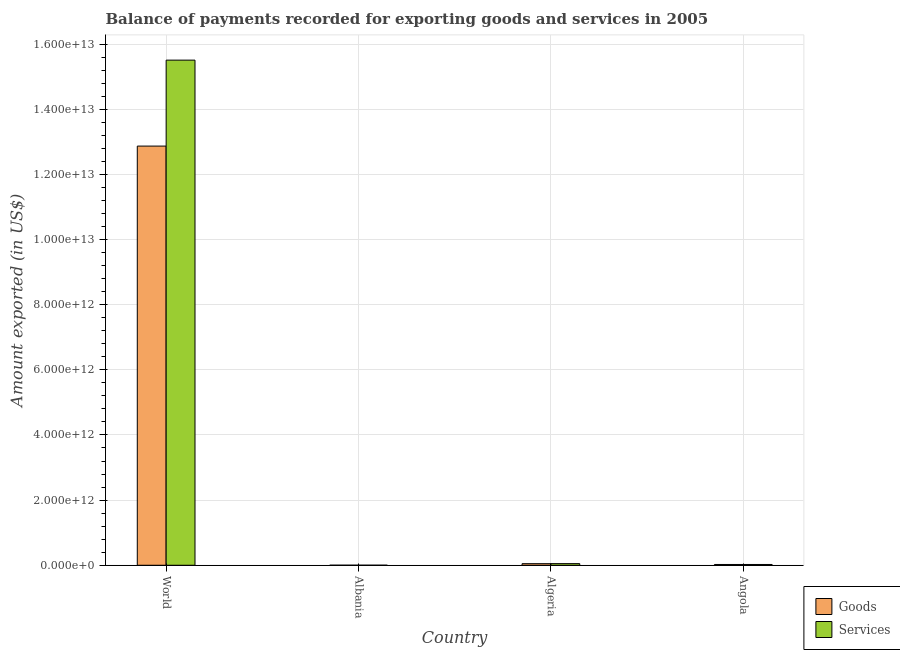How many groups of bars are there?
Ensure brevity in your answer.  4. How many bars are there on the 2nd tick from the left?
Provide a succinct answer. 2. How many bars are there on the 4th tick from the right?
Offer a very short reply. 2. What is the label of the 1st group of bars from the left?
Keep it short and to the point. World. In how many cases, is the number of bars for a given country not equal to the number of legend labels?
Offer a terse response. 0. What is the amount of goods exported in Angola?
Make the answer very short. 2.43e+1. Across all countries, what is the maximum amount of goods exported?
Provide a short and direct response. 1.29e+13. Across all countries, what is the minimum amount of goods exported?
Ensure brevity in your answer.  1.46e+09. In which country was the amount of services exported maximum?
Ensure brevity in your answer.  World. In which country was the amount of goods exported minimum?
Provide a succinct answer. Albania. What is the total amount of goods exported in the graph?
Your answer should be compact. 1.29e+13. What is the difference between the amount of goods exported in Albania and that in World?
Offer a very short reply. -1.29e+13. What is the difference between the amount of goods exported in Algeria and the amount of services exported in Albania?
Your response must be concise. 4.72e+1. What is the average amount of services exported per country?
Your response must be concise. 3.90e+12. What is the difference between the amount of services exported and amount of goods exported in Albania?
Your answer should be very brief. 2.27e+08. In how many countries, is the amount of services exported greater than 2000000000000 US$?
Your response must be concise. 1. What is the ratio of the amount of goods exported in Albania to that in World?
Provide a succinct answer. 0. Is the difference between the amount of services exported in Albania and World greater than the difference between the amount of goods exported in Albania and World?
Give a very brief answer. No. What is the difference between the highest and the second highest amount of services exported?
Offer a terse response. 1.55e+13. What is the difference between the highest and the lowest amount of services exported?
Ensure brevity in your answer.  1.55e+13. What does the 1st bar from the left in Albania represents?
Make the answer very short. Goods. What does the 1st bar from the right in Algeria represents?
Your answer should be very brief. Services. How many bars are there?
Your answer should be compact. 8. What is the difference between two consecutive major ticks on the Y-axis?
Make the answer very short. 2.00e+12. Does the graph contain any zero values?
Offer a terse response. No. Does the graph contain grids?
Ensure brevity in your answer.  Yes. Where does the legend appear in the graph?
Offer a terse response. Bottom right. How are the legend labels stacked?
Offer a very short reply. Vertical. What is the title of the graph?
Your answer should be compact. Balance of payments recorded for exporting goods and services in 2005. Does "Resident" appear as one of the legend labels in the graph?
Offer a terse response. No. What is the label or title of the Y-axis?
Give a very brief answer. Amount exported (in US$). What is the Amount exported (in US$) of Goods in World?
Your response must be concise. 1.29e+13. What is the Amount exported (in US$) of Services in World?
Give a very brief answer. 1.55e+13. What is the Amount exported (in US$) in Goods in Albania?
Offer a terse response. 1.46e+09. What is the Amount exported (in US$) in Services in Albania?
Keep it short and to the point. 1.69e+09. What is the Amount exported (in US$) in Goods in Algeria?
Your answer should be very brief. 4.88e+1. What is the Amount exported (in US$) in Services in Algeria?
Your response must be concise. 5.03e+1. What is the Amount exported (in US$) in Goods in Angola?
Provide a succinct answer. 2.43e+1. What is the Amount exported (in US$) in Services in Angola?
Your response must be concise. 2.43e+1. Across all countries, what is the maximum Amount exported (in US$) of Goods?
Offer a very short reply. 1.29e+13. Across all countries, what is the maximum Amount exported (in US$) of Services?
Provide a succinct answer. 1.55e+13. Across all countries, what is the minimum Amount exported (in US$) in Goods?
Your answer should be very brief. 1.46e+09. Across all countries, what is the minimum Amount exported (in US$) in Services?
Provide a short and direct response. 1.69e+09. What is the total Amount exported (in US$) in Goods in the graph?
Give a very brief answer. 1.29e+13. What is the total Amount exported (in US$) in Services in the graph?
Provide a succinct answer. 1.56e+13. What is the difference between the Amount exported (in US$) of Goods in World and that in Albania?
Give a very brief answer. 1.29e+13. What is the difference between the Amount exported (in US$) of Services in World and that in Albania?
Keep it short and to the point. 1.55e+13. What is the difference between the Amount exported (in US$) of Goods in World and that in Algeria?
Offer a very short reply. 1.28e+13. What is the difference between the Amount exported (in US$) in Services in World and that in Algeria?
Offer a terse response. 1.55e+13. What is the difference between the Amount exported (in US$) of Goods in World and that in Angola?
Provide a short and direct response. 1.28e+13. What is the difference between the Amount exported (in US$) in Services in World and that in Angola?
Provide a short and direct response. 1.55e+13. What is the difference between the Amount exported (in US$) in Goods in Albania and that in Algeria?
Your answer should be very brief. -4.74e+1. What is the difference between the Amount exported (in US$) of Services in Albania and that in Algeria?
Offer a very short reply. -4.86e+1. What is the difference between the Amount exported (in US$) of Goods in Albania and that in Angola?
Give a very brief answer. -2.28e+1. What is the difference between the Amount exported (in US$) of Services in Albania and that in Angola?
Your response must be concise. -2.26e+1. What is the difference between the Amount exported (in US$) in Goods in Algeria and that in Angola?
Give a very brief answer. 2.46e+1. What is the difference between the Amount exported (in US$) of Services in Algeria and that in Angola?
Ensure brevity in your answer.  2.60e+1. What is the difference between the Amount exported (in US$) in Goods in World and the Amount exported (in US$) in Services in Albania?
Your answer should be very brief. 1.29e+13. What is the difference between the Amount exported (in US$) of Goods in World and the Amount exported (in US$) of Services in Algeria?
Give a very brief answer. 1.28e+13. What is the difference between the Amount exported (in US$) in Goods in World and the Amount exported (in US$) in Services in Angola?
Keep it short and to the point. 1.28e+13. What is the difference between the Amount exported (in US$) of Goods in Albania and the Amount exported (in US$) of Services in Algeria?
Make the answer very short. -4.88e+1. What is the difference between the Amount exported (in US$) of Goods in Albania and the Amount exported (in US$) of Services in Angola?
Provide a succinct answer. -2.29e+1. What is the difference between the Amount exported (in US$) in Goods in Algeria and the Amount exported (in US$) in Services in Angola?
Ensure brevity in your answer.  2.45e+1. What is the average Amount exported (in US$) of Goods per country?
Offer a very short reply. 3.24e+12. What is the average Amount exported (in US$) of Services per country?
Your answer should be very brief. 3.90e+12. What is the difference between the Amount exported (in US$) in Goods and Amount exported (in US$) in Services in World?
Offer a terse response. -2.64e+12. What is the difference between the Amount exported (in US$) of Goods and Amount exported (in US$) of Services in Albania?
Provide a succinct answer. -2.27e+08. What is the difference between the Amount exported (in US$) of Goods and Amount exported (in US$) of Services in Algeria?
Ensure brevity in your answer.  -1.43e+09. What is the difference between the Amount exported (in US$) of Goods and Amount exported (in US$) of Services in Angola?
Your answer should be very brief. -2.58e+07. What is the ratio of the Amount exported (in US$) in Goods in World to that in Albania?
Ensure brevity in your answer.  8808.63. What is the ratio of the Amount exported (in US$) in Services in World to that in Albania?
Your response must be concise. 9189.13. What is the ratio of the Amount exported (in US$) in Goods in World to that in Algeria?
Make the answer very short. 263.46. What is the ratio of the Amount exported (in US$) in Services in World to that in Algeria?
Offer a terse response. 308.47. What is the ratio of the Amount exported (in US$) of Goods in World to that in Angola?
Offer a terse response. 529.82. What is the ratio of the Amount exported (in US$) of Services in World to that in Angola?
Your answer should be very brief. 637.8. What is the ratio of the Amount exported (in US$) of Goods in Albania to that in Algeria?
Your answer should be very brief. 0.03. What is the ratio of the Amount exported (in US$) in Services in Albania to that in Algeria?
Offer a very short reply. 0.03. What is the ratio of the Amount exported (in US$) of Goods in Albania to that in Angola?
Your answer should be compact. 0.06. What is the ratio of the Amount exported (in US$) of Services in Albania to that in Angola?
Provide a succinct answer. 0.07. What is the ratio of the Amount exported (in US$) in Goods in Algeria to that in Angola?
Provide a succinct answer. 2.01. What is the ratio of the Amount exported (in US$) in Services in Algeria to that in Angola?
Provide a short and direct response. 2.07. What is the difference between the highest and the second highest Amount exported (in US$) in Goods?
Offer a terse response. 1.28e+13. What is the difference between the highest and the second highest Amount exported (in US$) in Services?
Ensure brevity in your answer.  1.55e+13. What is the difference between the highest and the lowest Amount exported (in US$) in Goods?
Ensure brevity in your answer.  1.29e+13. What is the difference between the highest and the lowest Amount exported (in US$) in Services?
Provide a short and direct response. 1.55e+13. 